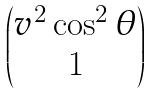<formula> <loc_0><loc_0><loc_500><loc_500>\begin{pmatrix} v ^ { 2 } \cos ^ { 2 } \theta \\ 1 \end{pmatrix}</formula> 